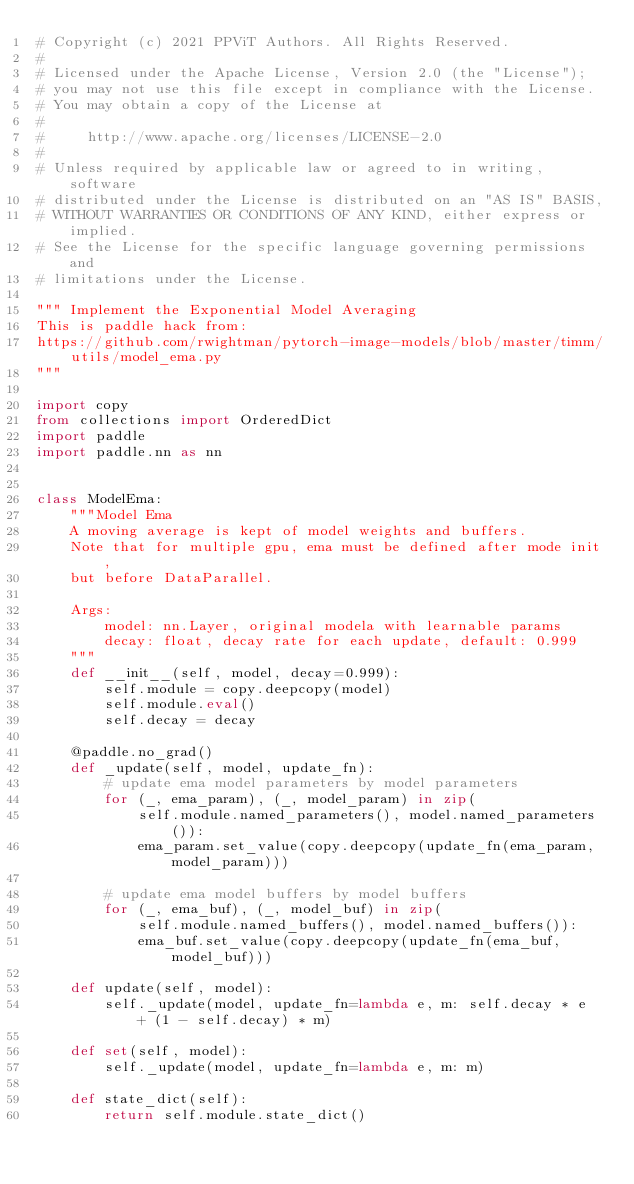Convert code to text. <code><loc_0><loc_0><loc_500><loc_500><_Python_># Copyright (c) 2021 PPViT Authors. All Rights Reserved.
#
# Licensed under the Apache License, Version 2.0 (the "License");
# you may not use this file except in compliance with the License.
# You may obtain a copy of the License at
#
#     http://www.apache.org/licenses/LICENSE-2.0
#
# Unless required by applicable law or agreed to in writing, software
# distributed under the License is distributed on an "AS IS" BASIS,
# WITHOUT WARRANTIES OR CONDITIONS OF ANY KIND, either express or implied.
# See the License for the specific language governing permissions and
# limitations under the License.

""" Implement the Exponential Model Averaging
This is paddle hack from:
https://github.com/rwightman/pytorch-image-models/blob/master/timm/utils/model_ema.py
"""

import copy
from collections import OrderedDict
import paddle
import paddle.nn as nn


class ModelEma:
    """Model Ema
    A moving average is kept of model weights and buffers.
    Note that for multiple gpu, ema must be defined after mode init,
    but before DataParallel.

    Args:
        model: nn.Layer, original modela with learnable params
        decay: float, decay rate for each update, default: 0.999
    """
    def __init__(self, model, decay=0.999):
        self.module = copy.deepcopy(model)
        self.module.eval()
        self.decay = decay

    @paddle.no_grad()
    def _update(self, model, update_fn):
        # update ema model parameters by model parameters
        for (_, ema_param), (_, model_param) in zip(
            self.module.named_parameters(), model.named_parameters()):
            ema_param.set_value(copy.deepcopy(update_fn(ema_param, model_param)))
            
        # update ema model buffers by model buffers
        for (_, ema_buf), (_, model_buf) in zip(
            self.module.named_buffers(), model.named_buffers()):
            ema_buf.set_value(copy.deepcopy(update_fn(ema_buf, model_buf)))

    def update(self, model):
        self._update(model, update_fn=lambda e, m: self.decay * e  + (1 - self.decay) * m)

    def set(self, model):
        self._update(model, update_fn=lambda e, m: m)

    def state_dict(self):
        return self.module.state_dict()
</code> 